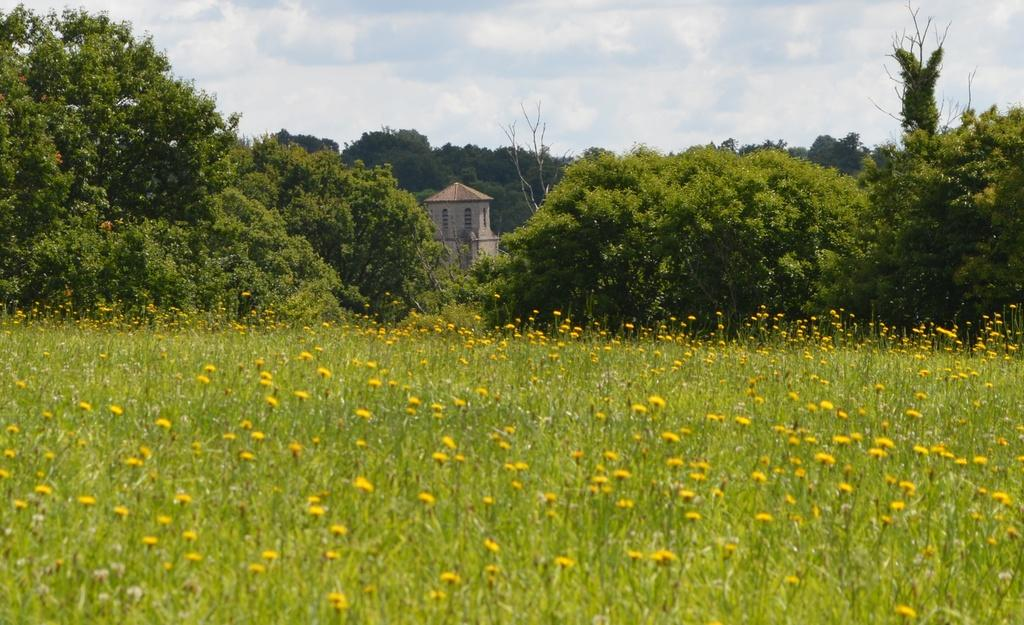What type of vegetation can be seen in the image? There are plants and flowers in the image. What can be seen in the background of the image? There are trees, a building, and the sky visible in the background of the image. What type of dress is the van wearing in the image? There is no van present in the image, and therefore no dress or any other clothing item can be associated with it. 